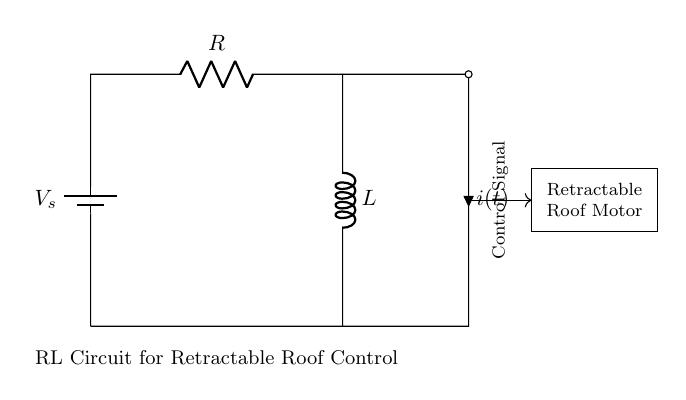What is the value of the resistance in the circuit? The diagram clearly labels the resistor as "R," but it does not provide an explicit numerical value. Therefore, we cannot determine the exact value of resistance without additional information.
Answer: R What does "L" represent in this circuit? In this context, "L" denotes the inductance of the inductor component of the RL circuit, which is used to control the retractable roof motor.
Answer: Inductor What is the purpose of the battery in the circuit? The battery provides the voltage source needed to power the circuit, specifically driving the current through the resistor and inductor to control the roof mechanism.
Answer: Voltage source What is the function of the motor in this RL circuit? The motor is responsible for executing the physical movement of the retractable roof in response to the control signal derived from the circuit’s active components.
Answer: Retractable roof movement How many components are in the circuit? The circuit features three main components: one resistor (R), one inductor (L), and one battery (voltage source). Counting these components gives us a total of three.
Answer: Three What does the control signal indicate in this circuit? The control signal denotes the demand from the circuit for the motor to either retract or extend the roof, depending on the desired position controlled by the RL behavior.
Answer: Roof position command What type of circuit is represented in this diagram? The diagram showcases a Resistor-Inductor circuit, which is specifically utilized for controlling inductive loads like motors in various applications.
Answer: RL circuit 